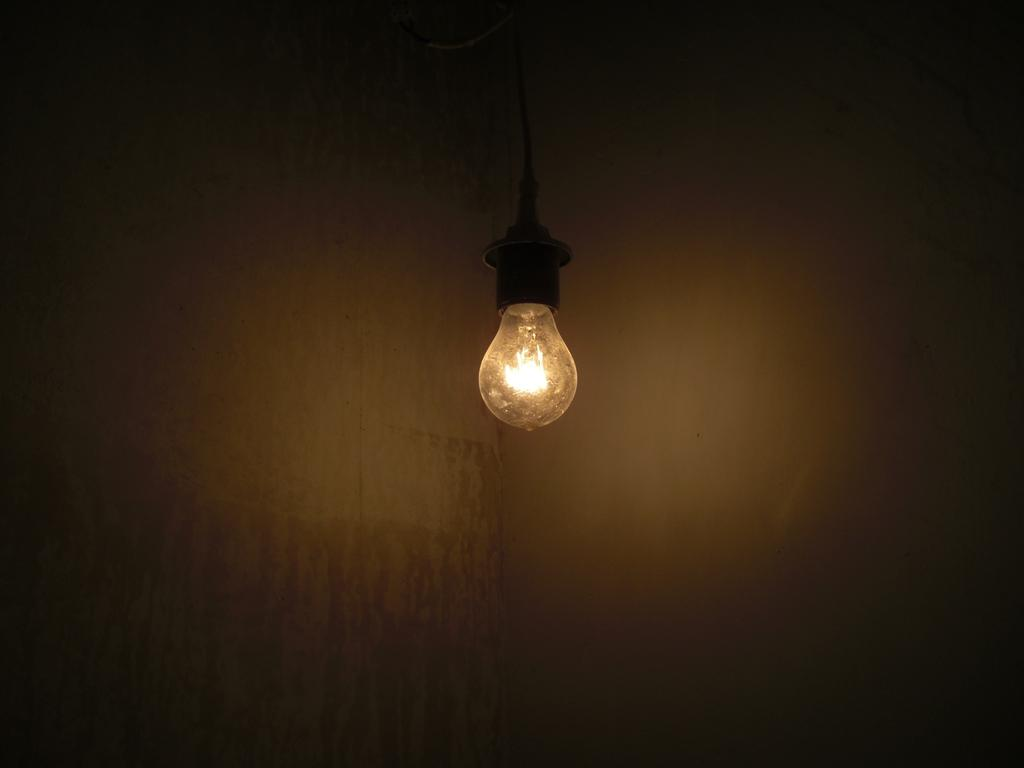What is the main object in the image? There is an electric bulb in the image. What can be seen in the background of the image? There is a wall in the background of the image. How many holes are visible in the electric bulb in the image? There are no visible holes in the electric bulb in the image. What color is the wall in the background of the image? The provided facts do not mention the color of the wall in the background of the image. 